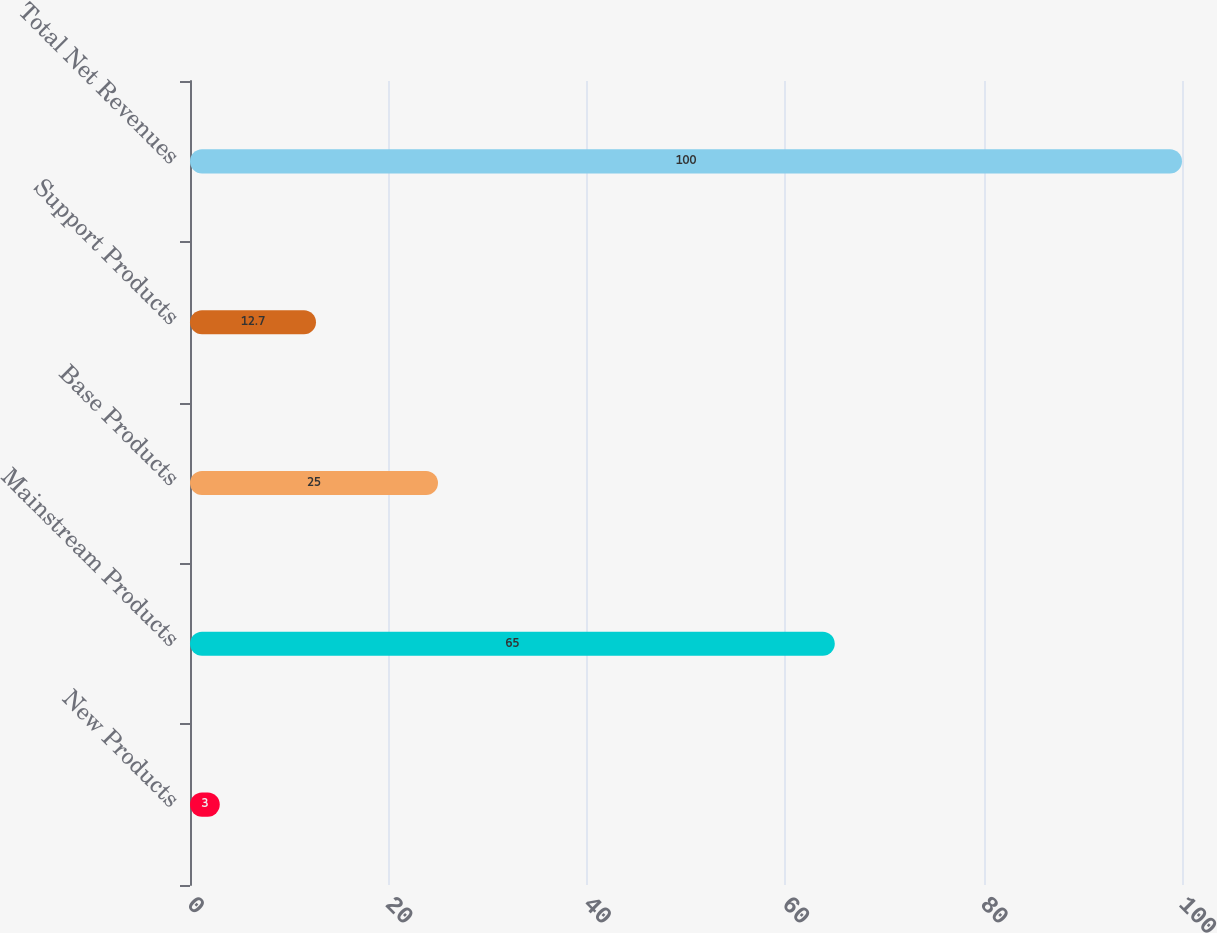<chart> <loc_0><loc_0><loc_500><loc_500><bar_chart><fcel>New Products<fcel>Mainstream Products<fcel>Base Products<fcel>Support Products<fcel>Total Net Revenues<nl><fcel>3<fcel>65<fcel>25<fcel>12.7<fcel>100<nl></chart> 